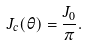<formula> <loc_0><loc_0><loc_500><loc_500>J _ { c } ( \theta ) = \frac { J _ { 0 } } { \pi } .</formula> 